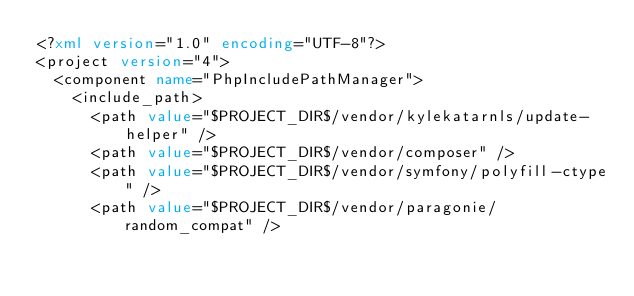Convert code to text. <code><loc_0><loc_0><loc_500><loc_500><_XML_><?xml version="1.0" encoding="UTF-8"?>
<project version="4">
  <component name="PhpIncludePathManager">
    <include_path>
      <path value="$PROJECT_DIR$/vendor/kylekatarnls/update-helper" />
      <path value="$PROJECT_DIR$/vendor/composer" />
      <path value="$PROJECT_DIR$/vendor/symfony/polyfill-ctype" />
      <path value="$PROJECT_DIR$/vendor/paragonie/random_compat" /></code> 